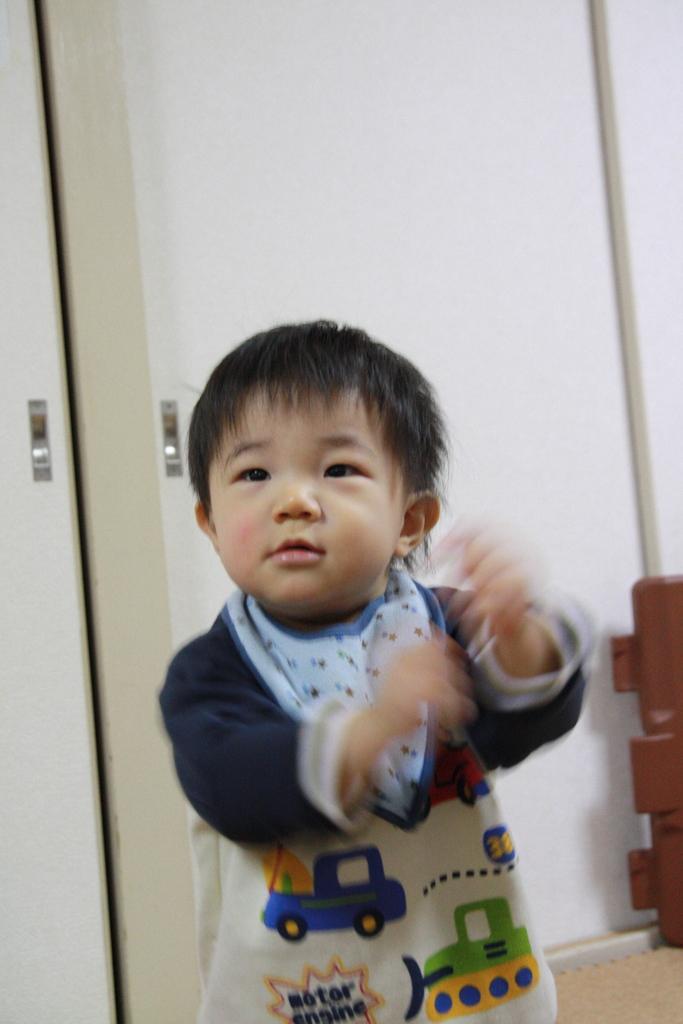Describe this image in one or two sentences. In this image in the foreground there is one boy who is standing, and in the background there are doors, wall and object. 